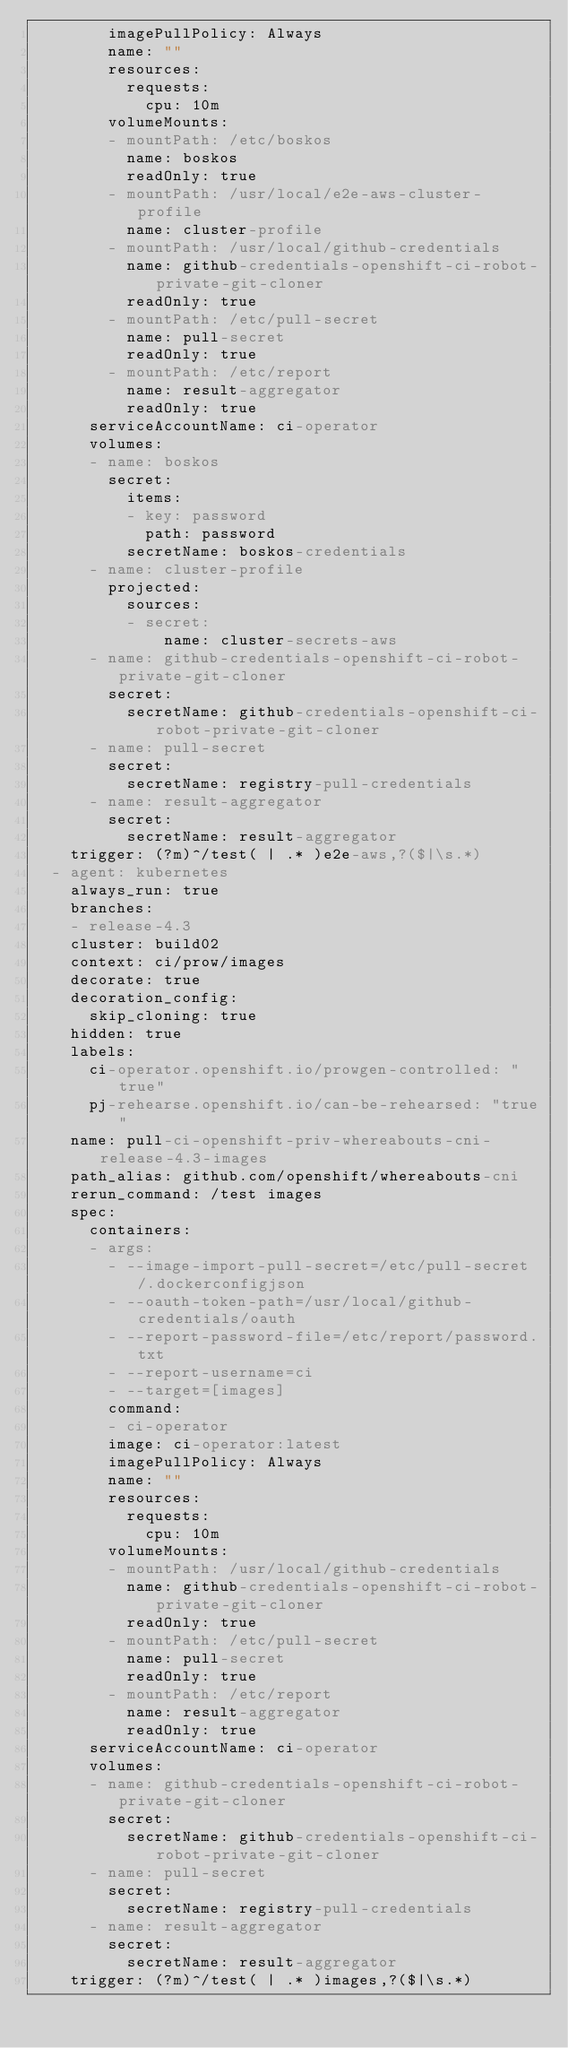<code> <loc_0><loc_0><loc_500><loc_500><_YAML_>        imagePullPolicy: Always
        name: ""
        resources:
          requests:
            cpu: 10m
        volumeMounts:
        - mountPath: /etc/boskos
          name: boskos
          readOnly: true
        - mountPath: /usr/local/e2e-aws-cluster-profile
          name: cluster-profile
        - mountPath: /usr/local/github-credentials
          name: github-credentials-openshift-ci-robot-private-git-cloner
          readOnly: true
        - mountPath: /etc/pull-secret
          name: pull-secret
          readOnly: true
        - mountPath: /etc/report
          name: result-aggregator
          readOnly: true
      serviceAccountName: ci-operator
      volumes:
      - name: boskos
        secret:
          items:
          - key: password
            path: password
          secretName: boskos-credentials
      - name: cluster-profile
        projected:
          sources:
          - secret:
              name: cluster-secrets-aws
      - name: github-credentials-openshift-ci-robot-private-git-cloner
        secret:
          secretName: github-credentials-openshift-ci-robot-private-git-cloner
      - name: pull-secret
        secret:
          secretName: registry-pull-credentials
      - name: result-aggregator
        secret:
          secretName: result-aggregator
    trigger: (?m)^/test( | .* )e2e-aws,?($|\s.*)
  - agent: kubernetes
    always_run: true
    branches:
    - release-4.3
    cluster: build02
    context: ci/prow/images
    decorate: true
    decoration_config:
      skip_cloning: true
    hidden: true
    labels:
      ci-operator.openshift.io/prowgen-controlled: "true"
      pj-rehearse.openshift.io/can-be-rehearsed: "true"
    name: pull-ci-openshift-priv-whereabouts-cni-release-4.3-images
    path_alias: github.com/openshift/whereabouts-cni
    rerun_command: /test images
    spec:
      containers:
      - args:
        - --image-import-pull-secret=/etc/pull-secret/.dockerconfigjson
        - --oauth-token-path=/usr/local/github-credentials/oauth
        - --report-password-file=/etc/report/password.txt
        - --report-username=ci
        - --target=[images]
        command:
        - ci-operator
        image: ci-operator:latest
        imagePullPolicy: Always
        name: ""
        resources:
          requests:
            cpu: 10m
        volumeMounts:
        - mountPath: /usr/local/github-credentials
          name: github-credentials-openshift-ci-robot-private-git-cloner
          readOnly: true
        - mountPath: /etc/pull-secret
          name: pull-secret
          readOnly: true
        - mountPath: /etc/report
          name: result-aggregator
          readOnly: true
      serviceAccountName: ci-operator
      volumes:
      - name: github-credentials-openshift-ci-robot-private-git-cloner
        secret:
          secretName: github-credentials-openshift-ci-robot-private-git-cloner
      - name: pull-secret
        secret:
          secretName: registry-pull-credentials
      - name: result-aggregator
        secret:
          secretName: result-aggregator
    trigger: (?m)^/test( | .* )images,?($|\s.*)
</code> 